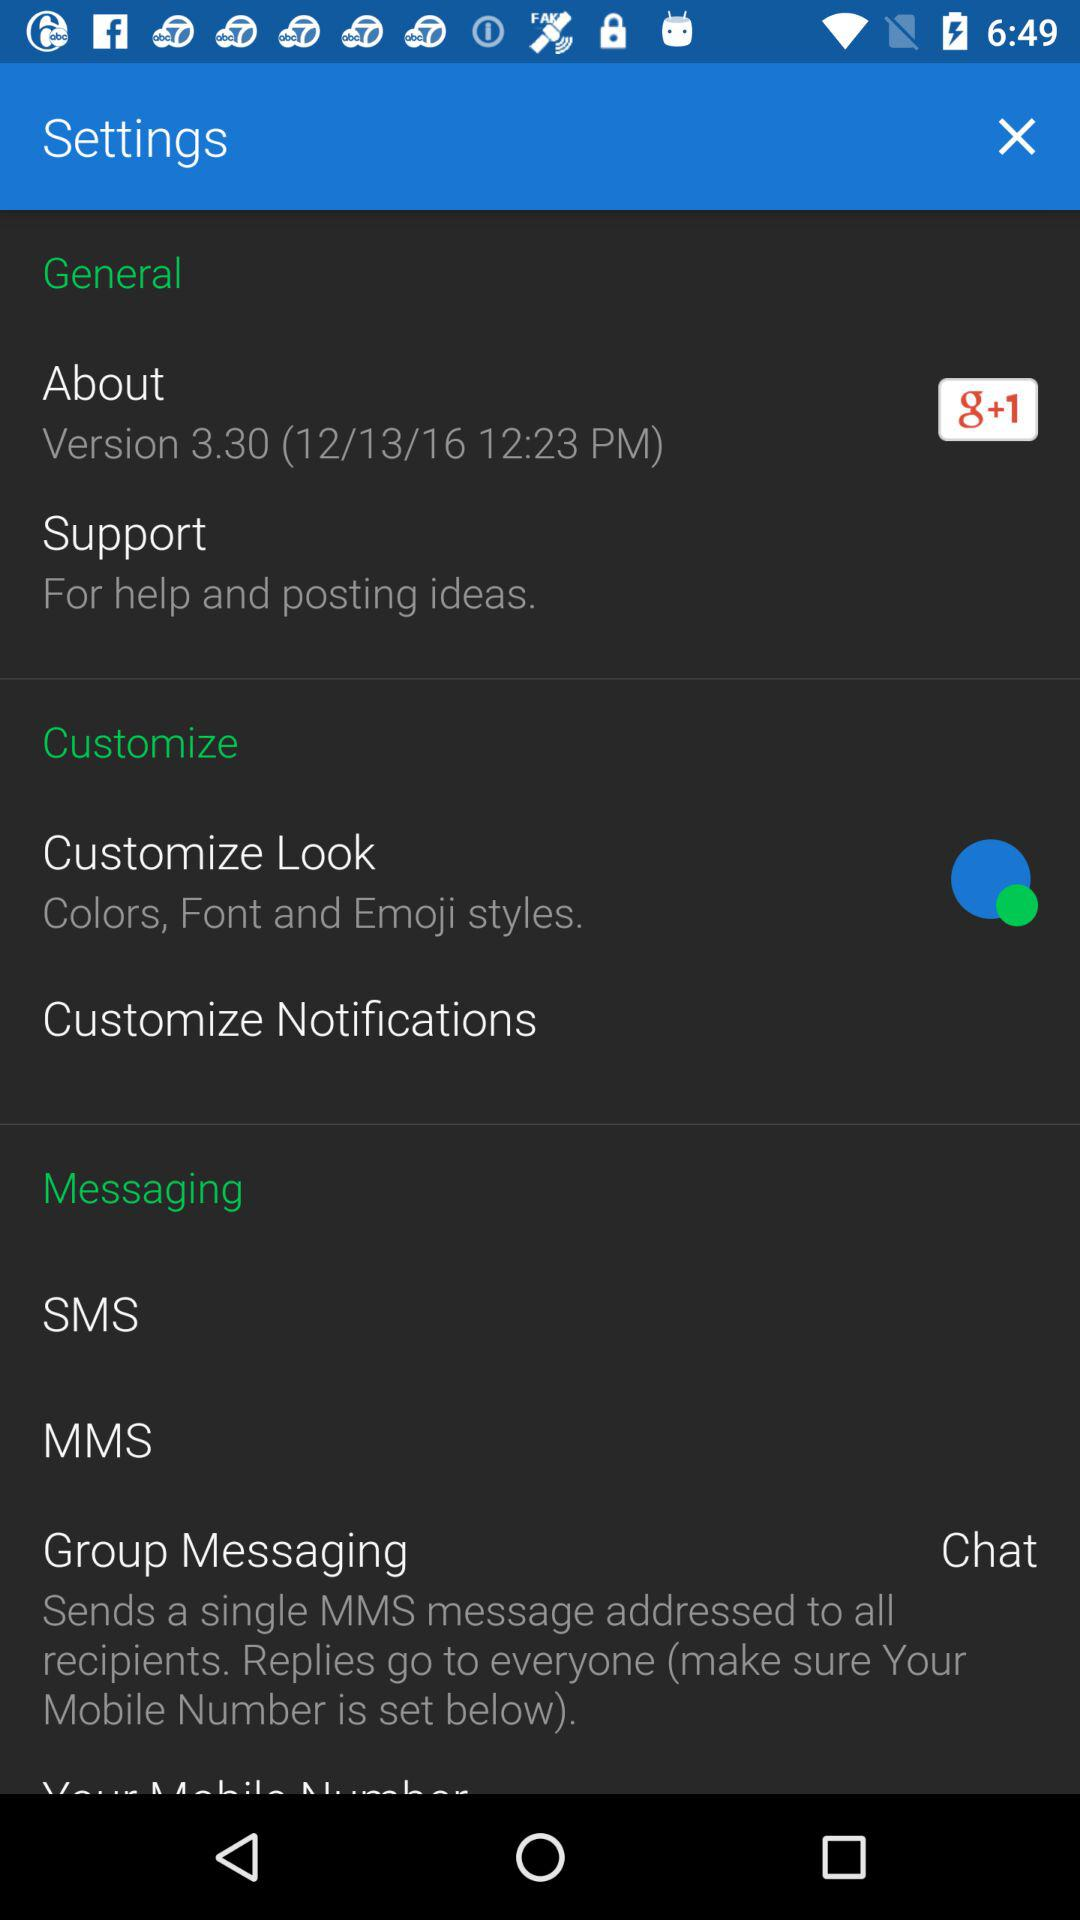On what date was the version released? The version was released on December 13, 2016. 